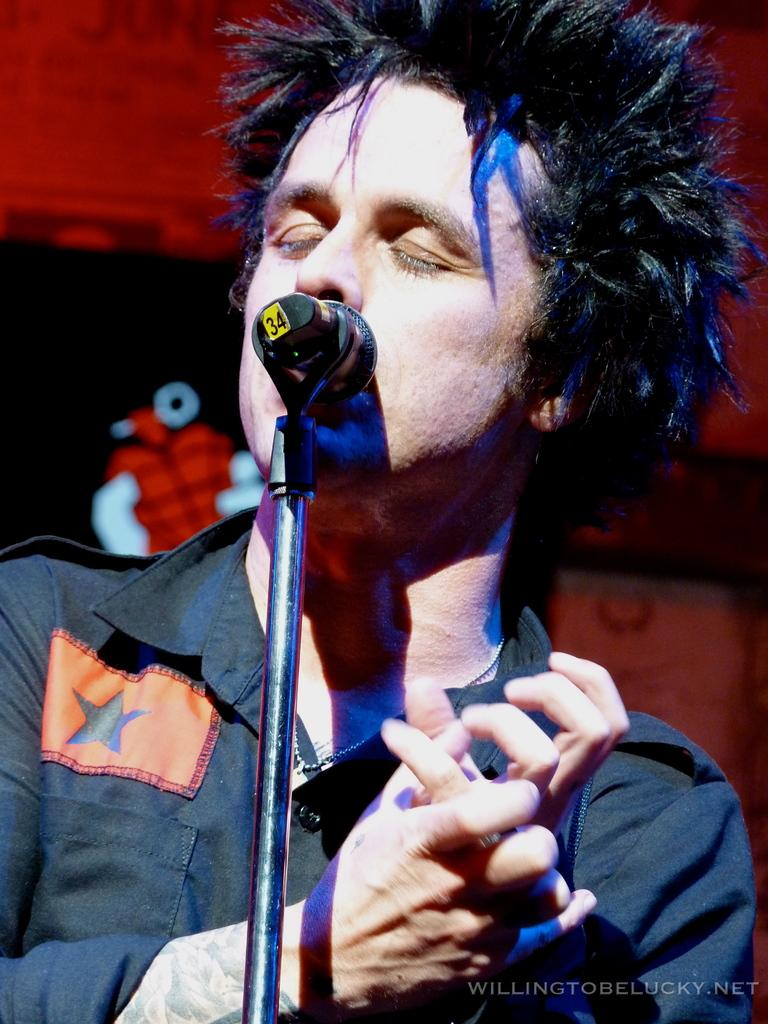Who is present in the image? There is a man in the image. What is the man wearing? The man is wearing a shirt. What can be seen in front of the man? There is a mic stand in front of the man. Is there any text or logo visible in the image? Yes, there is a watermark in the right bottom corner of the image. Where are the dolls sitting in the image? There are no dolls present in the image. What type of apple is the man holding in the image? There is no apple visible in the image. 